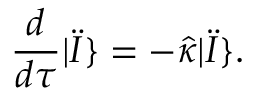<formula> <loc_0><loc_0><loc_500><loc_500>\frac { d } { d \tau } | \ddot { I } \} = - \hat { \kappa } | \ddot { I } \} .</formula> 